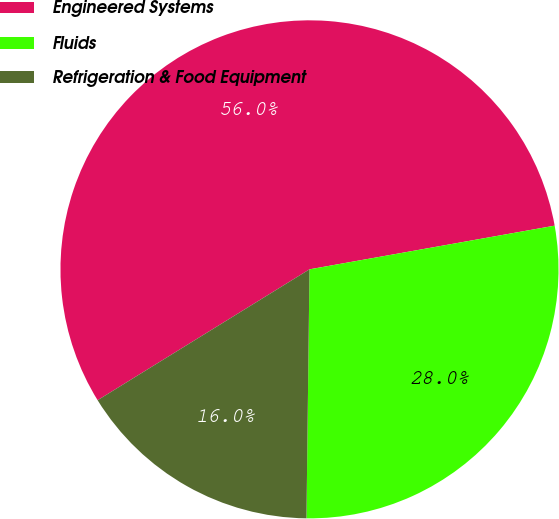<chart> <loc_0><loc_0><loc_500><loc_500><pie_chart><fcel>Engineered Systems<fcel>Fluids<fcel>Refrigeration & Food Equipment<nl><fcel>56.0%<fcel>28.0%<fcel>16.0%<nl></chart> 